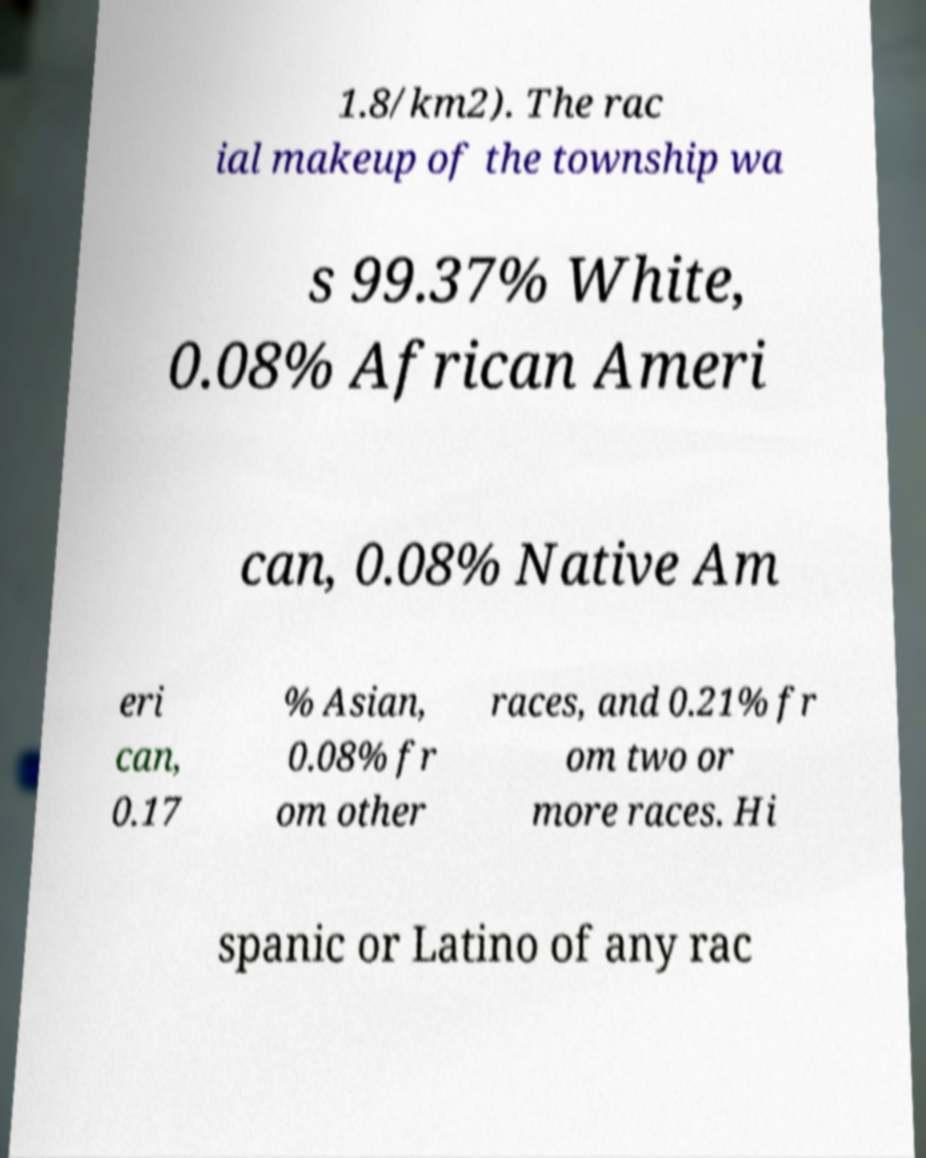Please read and relay the text visible in this image. What does it say? 1.8/km2). The rac ial makeup of the township wa s 99.37% White, 0.08% African Ameri can, 0.08% Native Am eri can, 0.17 % Asian, 0.08% fr om other races, and 0.21% fr om two or more races. Hi spanic or Latino of any rac 